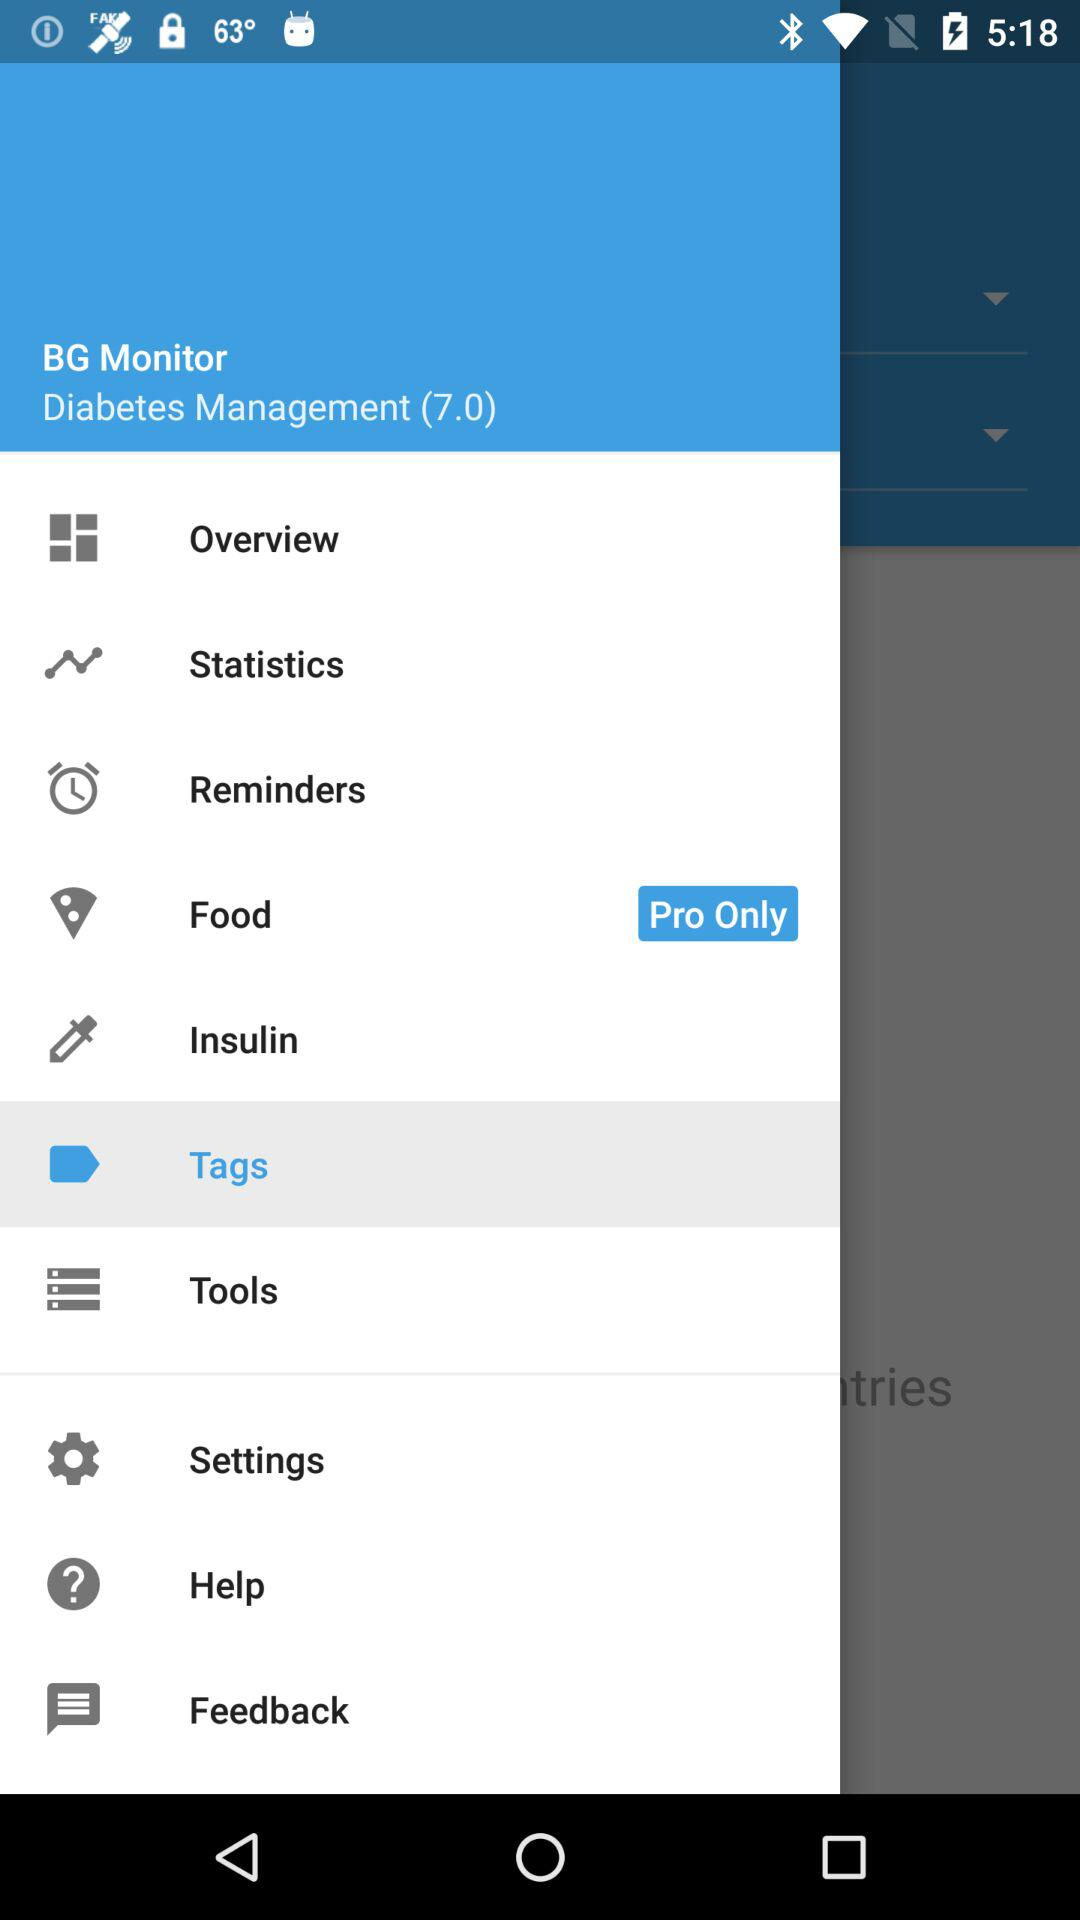What item is available only in the pro version? The item that is available only in the pro version is "Food". 